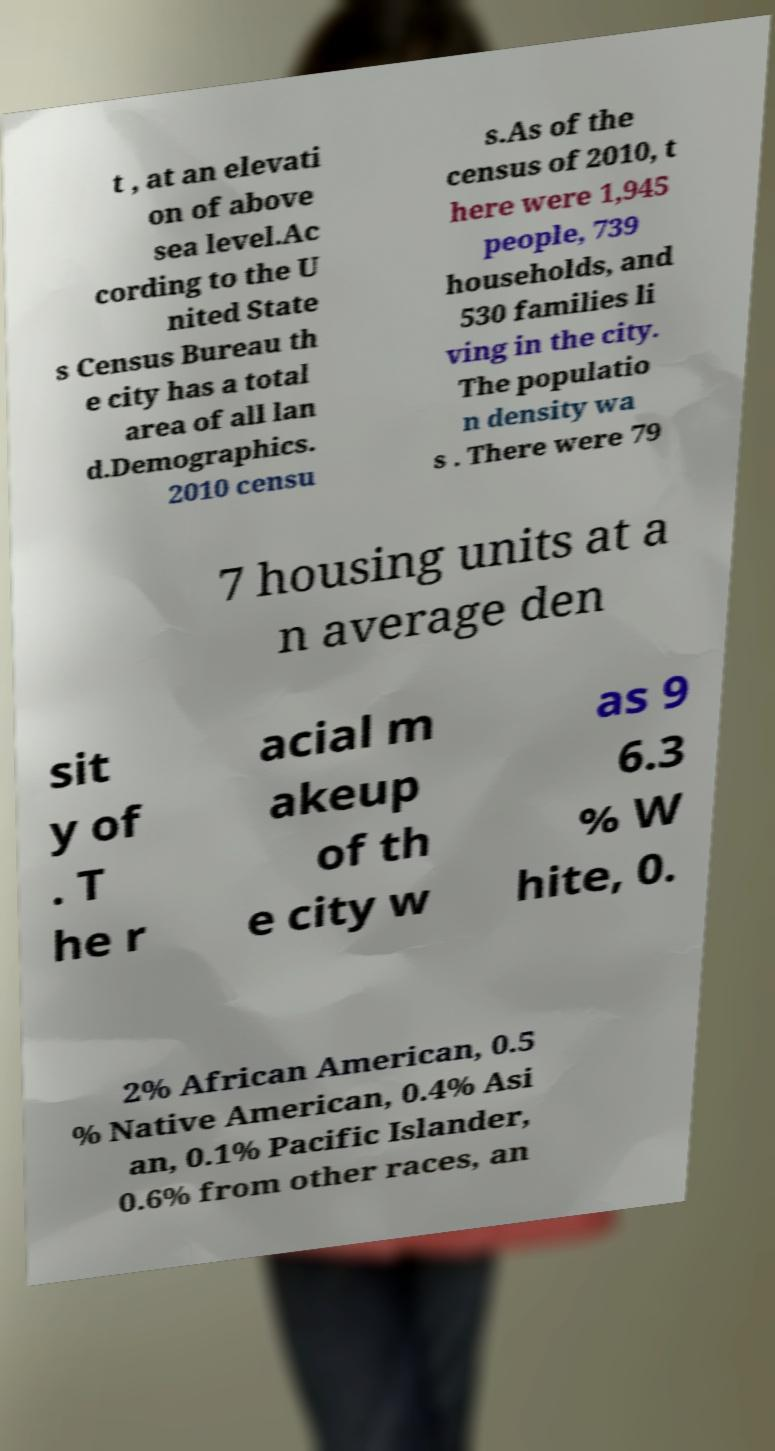Please read and relay the text visible in this image. What does it say? t , at an elevati on of above sea level.Ac cording to the U nited State s Census Bureau th e city has a total area of all lan d.Demographics. 2010 censu s.As of the census of 2010, t here were 1,945 people, 739 households, and 530 families li ving in the city. The populatio n density wa s . There were 79 7 housing units at a n average den sit y of . T he r acial m akeup of th e city w as 9 6.3 % W hite, 0. 2% African American, 0.5 % Native American, 0.4% Asi an, 0.1% Pacific Islander, 0.6% from other races, an 